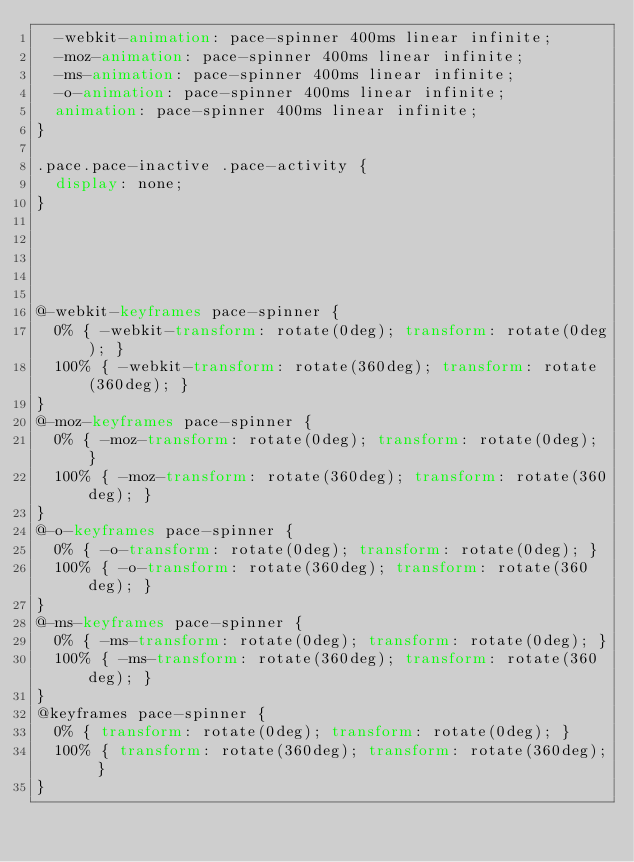Convert code to text. <code><loc_0><loc_0><loc_500><loc_500><_CSS_>  -webkit-animation: pace-spinner 400ms linear infinite;
  -moz-animation: pace-spinner 400ms linear infinite;
  -ms-animation: pace-spinner 400ms linear infinite;
  -o-animation: pace-spinner 400ms linear infinite;
  animation: pace-spinner 400ms linear infinite;
}

.pace.pace-inactive .pace-activity {
  display: none;
}





@-webkit-keyframes pace-spinner {
  0% { -webkit-transform: rotate(0deg); transform: rotate(0deg); }
  100% { -webkit-transform: rotate(360deg); transform: rotate(360deg); }
}
@-moz-keyframes pace-spinner {
  0% { -moz-transform: rotate(0deg); transform: rotate(0deg); }
  100% { -moz-transform: rotate(360deg); transform: rotate(360deg); }
}
@-o-keyframes pace-spinner {
  0% { -o-transform: rotate(0deg); transform: rotate(0deg); }
  100% { -o-transform: rotate(360deg); transform: rotate(360deg); }
}
@-ms-keyframes pace-spinner {
  0% { -ms-transform: rotate(0deg); transform: rotate(0deg); }
  100% { -ms-transform: rotate(360deg); transform: rotate(360deg); }
}
@keyframes pace-spinner {
  0% { transform: rotate(0deg); transform: rotate(0deg); }
  100% { transform: rotate(360deg); transform: rotate(360deg); }
}


</code> 